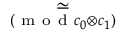<formula> <loc_0><loc_0><loc_500><loc_500>\underset { ( m o d { c _ { 0 } \otimes c _ { 1 } } ) } { \simeq }</formula> 